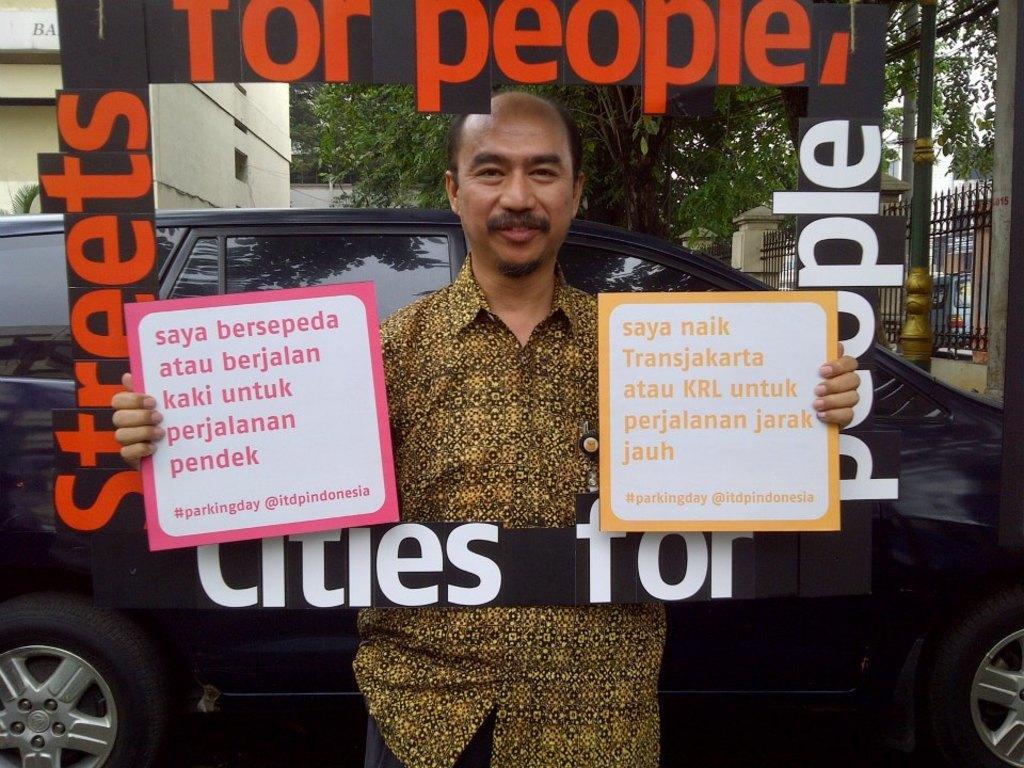Could you give a brief overview of what you see in this image? In the center of the image there is a person standing with the boards. In the background we can see car, trees, vehicle and fencing. 